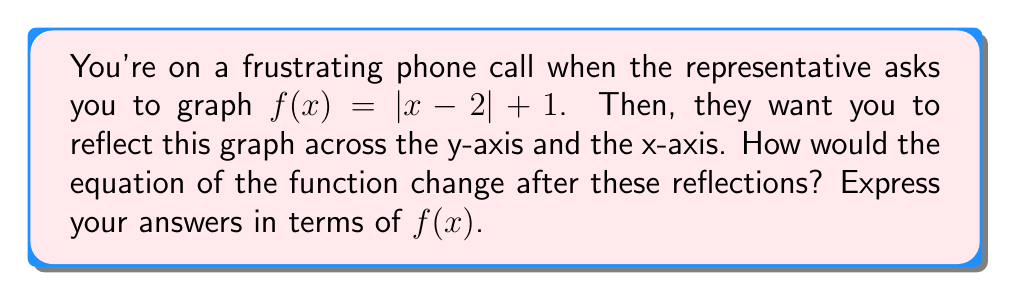Solve this math problem. Let's approach this step-by-step:

1) First, let's consider the reflection across the y-axis:
   - Reflecting across the y-axis changes x to -x in the original function.
   - So, $f(x) = |x - 2| + 1$ becomes $|-x - 2| + 1$
   - This can be written as $f(-x)$

2) Now, for the reflection across the x-axis:
   - Reflecting across the x-axis negates the entire function.
   - So, $f(x) = |x - 2| + 1$ becomes $-\left(|x - 2| + 1\right)$
   - This can be written as $-f(x)$

3) To express these in terms of $f(x)$ as requested:
   - Reflection across y-axis: $f(-x)$
   - Reflection across x-axis: $-f(x)$

Remember, when reflecting across the y-axis, we replace x with -x inside the function. When reflecting across the x-axis, we negate the entire function.
Answer: y-axis reflection: $f(-x)$; x-axis reflection: $-f(x)$ 